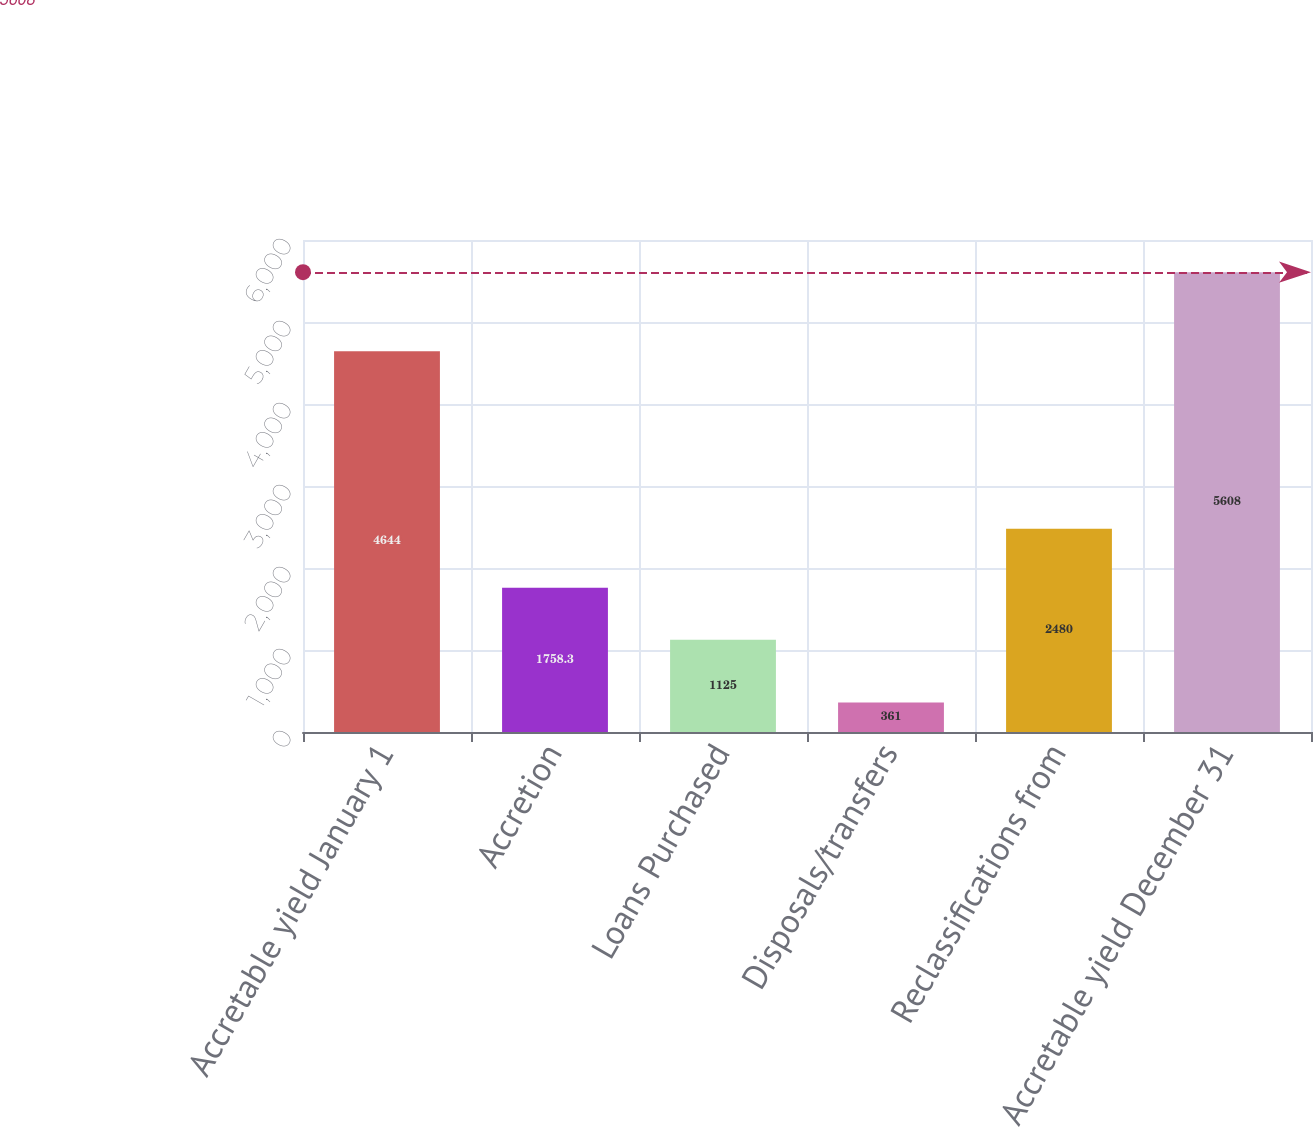Convert chart. <chart><loc_0><loc_0><loc_500><loc_500><bar_chart><fcel>Accretable yield January 1<fcel>Accretion<fcel>Loans Purchased<fcel>Disposals/transfers<fcel>Reclassifications from<fcel>Accretable yield December 31<nl><fcel>4644<fcel>1758.3<fcel>1125<fcel>361<fcel>2480<fcel>5608<nl></chart> 